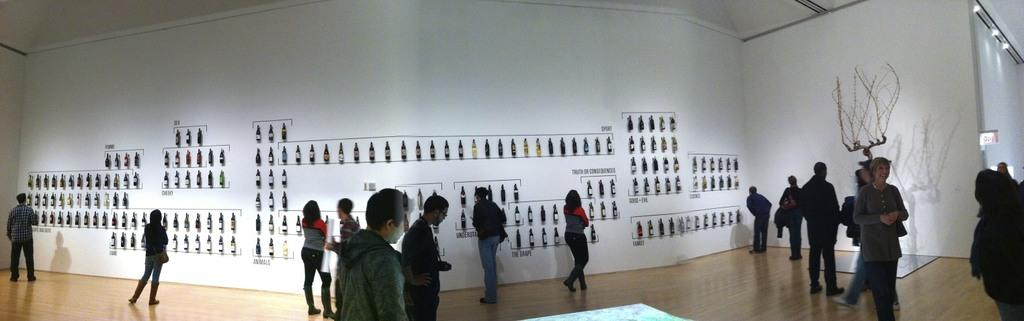What is happening with the group of people in the image? Some people are standing, while others are walking. Are there any objects on the wall in the image? Yes, there are bottles on the wall in the image. What can be seen in the image that provides illumination? There are lights visible in the image. What type of beam is being used by the fairies in the image? There are no fairies present in the image, and therefore no beam is being used by them. 